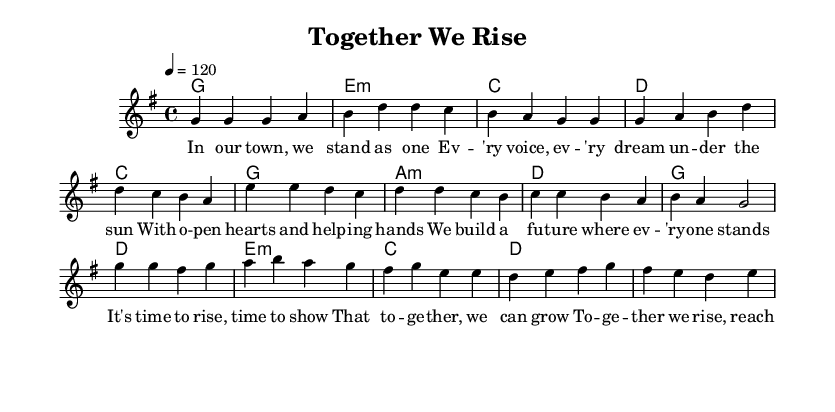What is the key signature of this music? The key signature is G major, which has one sharp (F#).
Answer: G major What is the time signature of this music? The time signature, indicated at the beginning of the music, is 4/4, meaning there are four beats in each measure.
Answer: 4/4 What is the tempo marking for this music? The tempo marking is indicated as 4 = 120, which means there are 120 beats per minute.
Answer: 120 How many measures are in the chorus? The chorus consists of four measures, as can be counted in the score section designated for the chorus.
Answer: 4 What chords are used in the pre-chorus? The chords used in the pre-chorus are C, G, A minor, and D. This is derived from the chord progression shown in the harmonies section.
Answer: C, G, A minor, D What is the predominant theme of the lyrics in this piece? The lyrics focus on themes of community involvement and collective strength, highlighted in phrases such as "together we rise" and "community strong."
Answer: Community involvement Which section of the song contains the message of growth together? The pre-chorus delivers the message about growth together with the line "That together, we can grow."
Answer: Pre-Chorus 